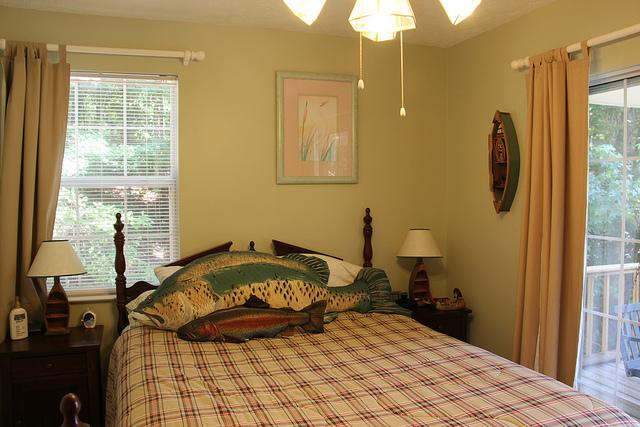What type of food is the animal on the bed classified as?

Choices:
A) seafood
B) beef
C) meat
D) legumes seafood 